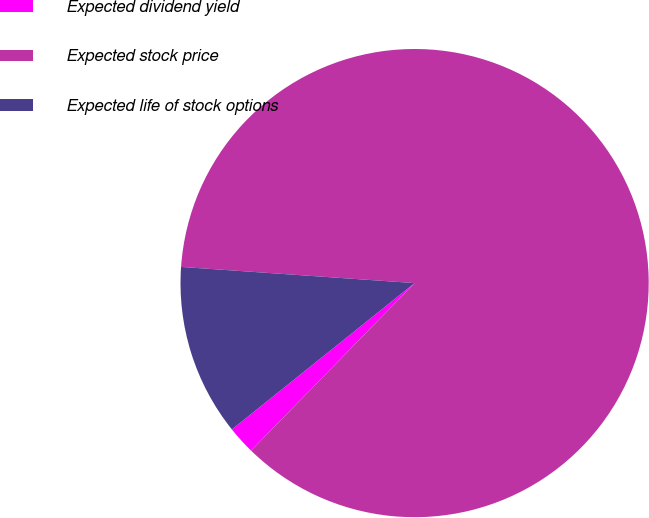Convert chart to OTSL. <chart><loc_0><loc_0><loc_500><loc_500><pie_chart><fcel>Expected dividend yield<fcel>Expected stock price<fcel>Expected life of stock options<nl><fcel>1.94%<fcel>86.21%<fcel>11.85%<nl></chart> 